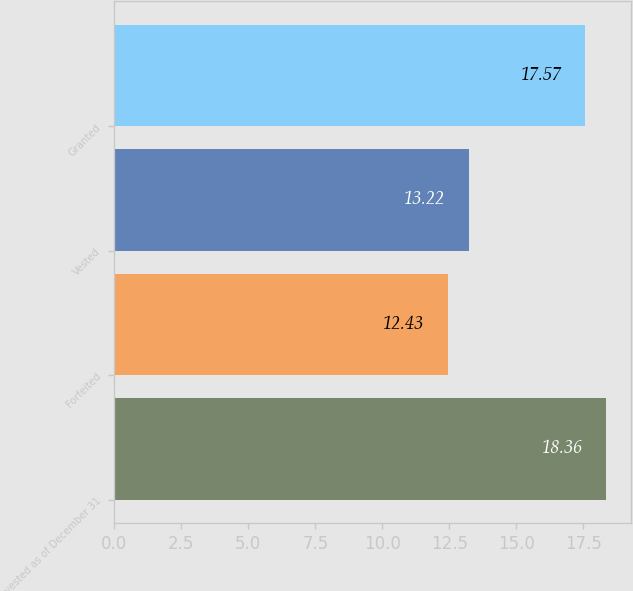Convert chart. <chart><loc_0><loc_0><loc_500><loc_500><bar_chart><fcel>Unvested as of December 31<fcel>Forfeited<fcel>Vested<fcel>Granted<nl><fcel>18.36<fcel>12.43<fcel>13.22<fcel>17.57<nl></chart> 